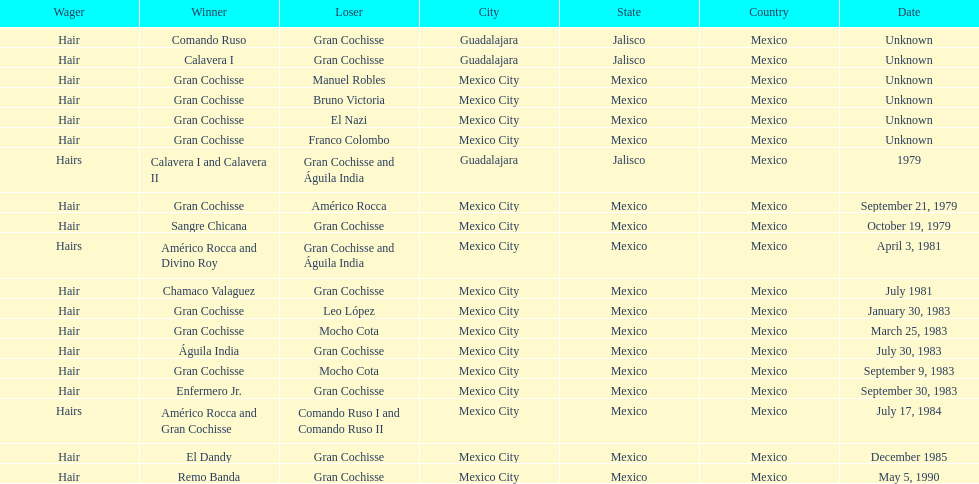How many games more than chamaco valaguez did sangre chicana win? 0. 